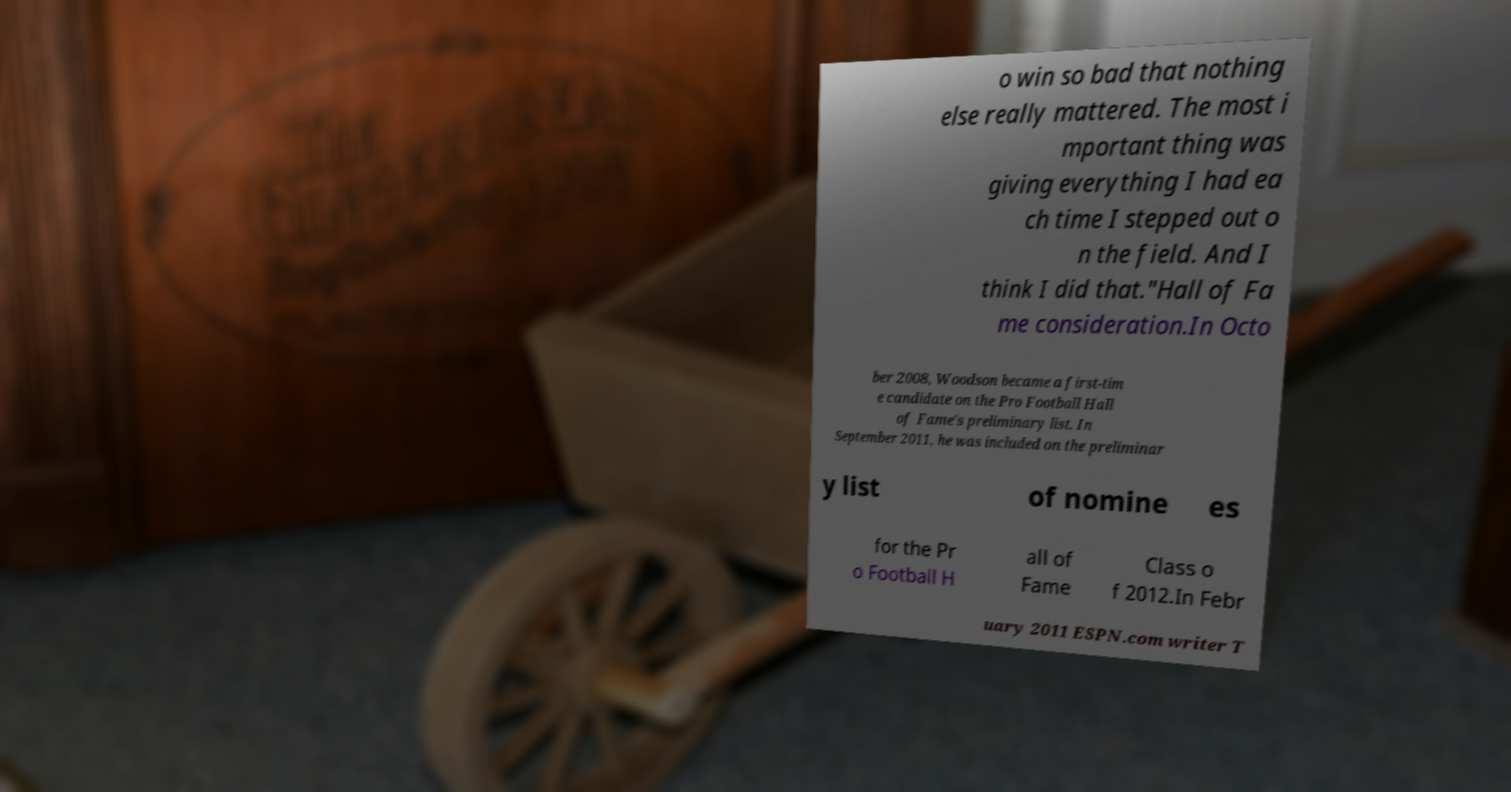For documentation purposes, I need the text within this image transcribed. Could you provide that? o win so bad that nothing else really mattered. The most i mportant thing was giving everything I had ea ch time I stepped out o n the field. And I think I did that."Hall of Fa me consideration.In Octo ber 2008, Woodson became a first-tim e candidate on the Pro Football Hall of Fame's preliminary list. In September 2011, he was included on the preliminar y list of nomine es for the Pr o Football H all of Fame Class o f 2012.In Febr uary 2011 ESPN.com writer T 